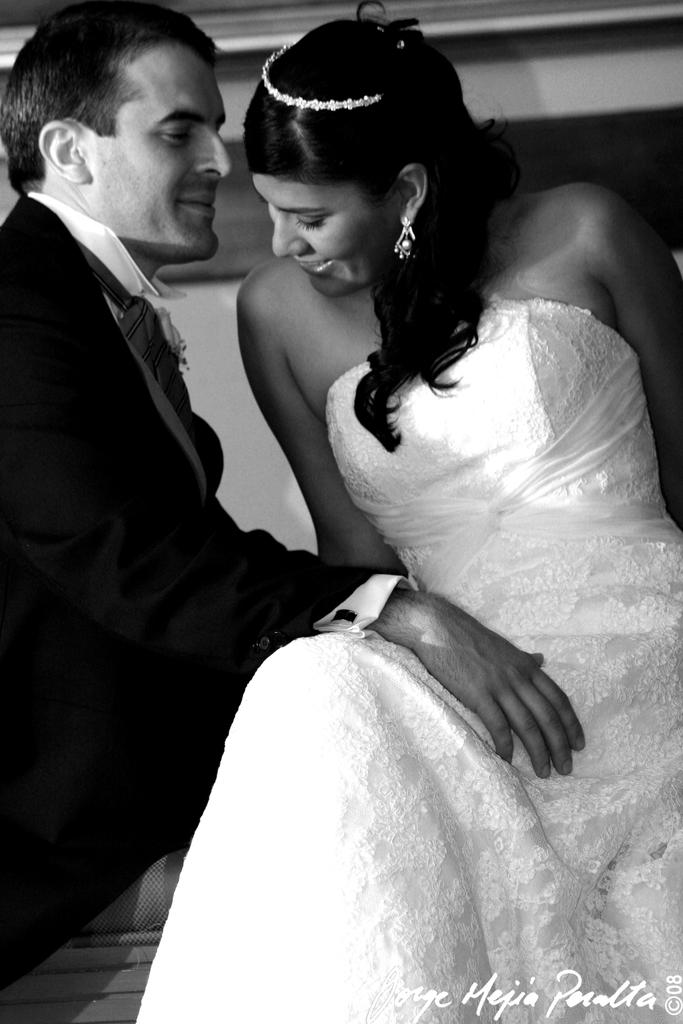What is the color scheme of the image? The image is black and white. What can be seen on the left side of the image? There is a man standing on the left side of the image. What can be seen on the right side of the image? There is a woman standing on the right side of the image. What type of jam is being spread on the company's logo in the image? There is no jam or company logo present in the image. What color is the thread used to sew the woman's dress in the image? There is no visible thread or dress in the image, as it is black and white and only features a man and a woman standing. 